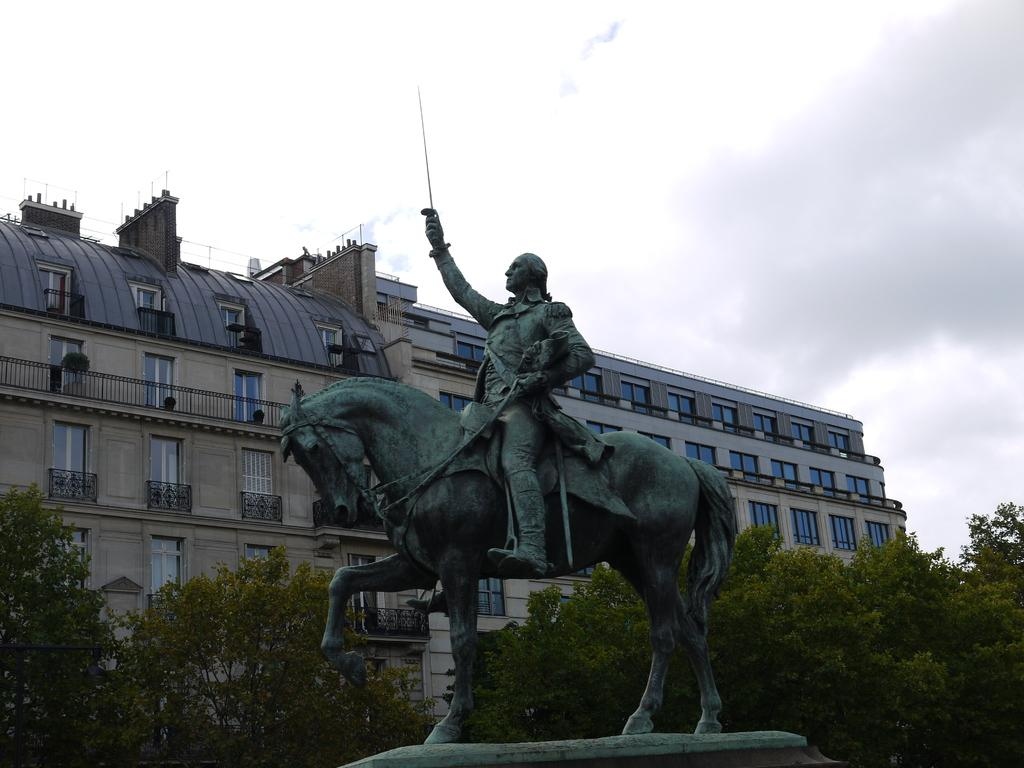What is the main subject of the sculpture in the image? The sculpture in the image depicts a person sitting on a horse. What type of structure can be seen in the image? There is a building in the image. What feature of the building is mentioned in the facts? The building has windows. What natural elements are visible in the image? Trees and the sky are visible in the image. What is the person's memory of the horse in the image? The image does not provide any information about the person's memory or thoughts, so it cannot be determined from the image. 